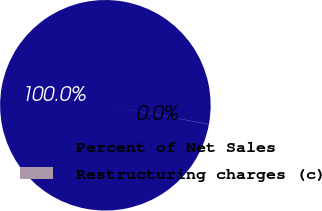Convert chart. <chart><loc_0><loc_0><loc_500><loc_500><pie_chart><fcel>Percent of Net Sales<fcel>Restructuring charges (c)<nl><fcel>99.98%<fcel>0.02%<nl></chart> 